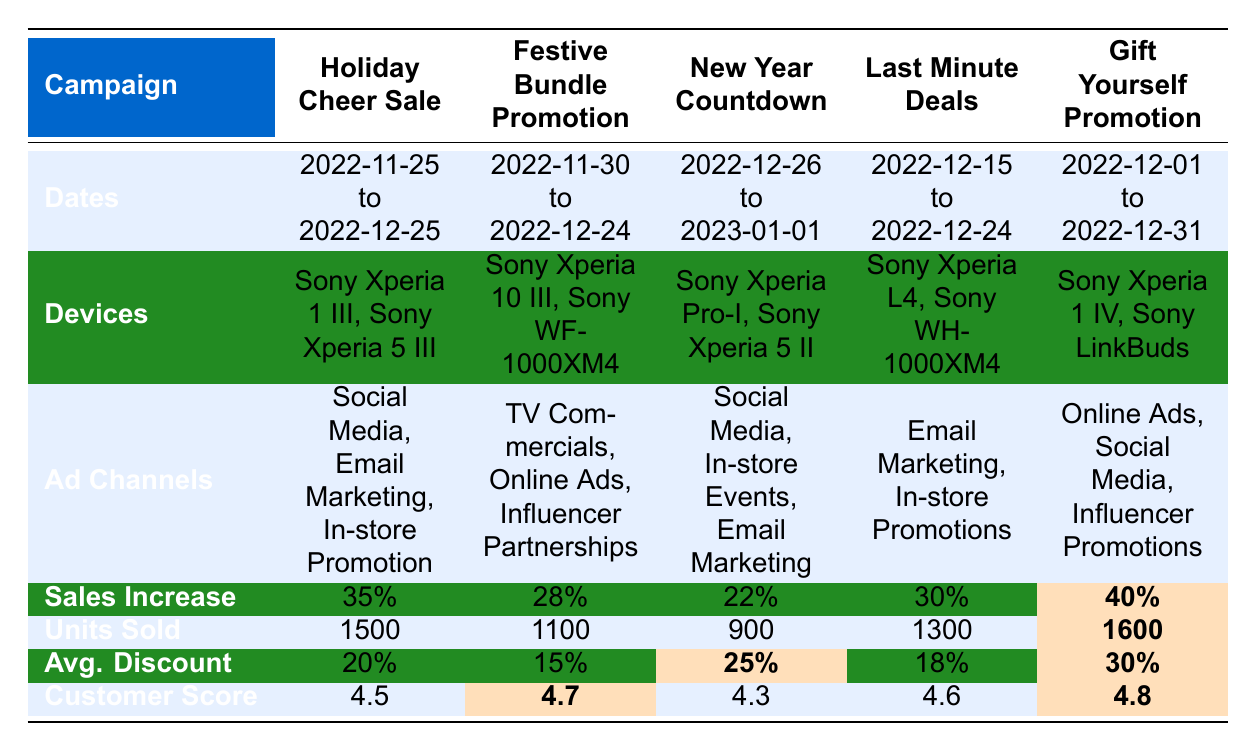What is the sales increase percentage for the "Gift Yourself Promotion" campaign? The sales increase percentage is explicitly listed under the "Sales Increase" row for the "Gift Yourself Promotion" campaign in the table. It shows a value of 40%.
Answer: 40% Which campaign had the highest customer feedback score? The customer feedback scores for each campaign are listed in the "Customer Score" row. Upon checking these values, the "Gift Yourself Promotion" campaign has the highest score of 4.8.
Answer: Gift Yourself Promotion How many total units were sold across all campaigns? To find the total units sold, add the units sold for each campaign: 1500 + 1100 + 900 + 1300 + 1600 = 5400.
Answer: 5400 Which ad channel was used in the "Holiday Cheer Sale"? The ad channel used for the "Holiday Cheer Sale" is listed in the "Ad Channels" row. It shows "Social Media, Email Marketing, In-store Promotion".
Answer: Social Media, Email Marketing, In-store Promotion What is the average discount offered across all campaigns? First, gather the average discounts: 20%, 15%, 25%, 18%, and 30%. Then, add these values: 20 + 15 + 25 + 18 + 30 = 108. Divide by the number of campaigns (5), resulting in an average of 108/5 = 21.6%.
Answer: 21.6% Did the "New Year Countdown" campaign have a sales increase percentage greater than 25%? The "New Year Countdown" campaign has a sales increase percentage of 22%, which is less than 25%. Therefore, the statement is false.
Answer: No What is the difference in total units sold between the "Gift Yourself Promotion" and "Festive Bundle Promotion"? The total units sold for the "Gift Yourself Promotion" is 1600, and for the "Festive Bundle Promotion" it is 1100. To find the difference, calculate 1600 - 1100 = 500.
Answer: 500 Which campaign had the lowest sales increase percentage and what is that percentage? The sales increase percentages for each campaign are compared. The lowest percentage is 22% for the "New Year Countdown" campaign.
Answer: New Year Countdown, 22% How many more total units were sold in the "Holiday Cheer Sale" than in the "Last Minute Deals"? The "Holiday Cheer Sale" sold 1500 units, whereas "Last Minute Deals" sold 1300 units. The difference is 1500 - 1300 = 200.
Answer: 200 What percentage discount was offered for the "Festive Bundle Promotion"? The table specifies the average discount offered for the "Festive Bundle Promotion" as 15%.
Answer: 15% 